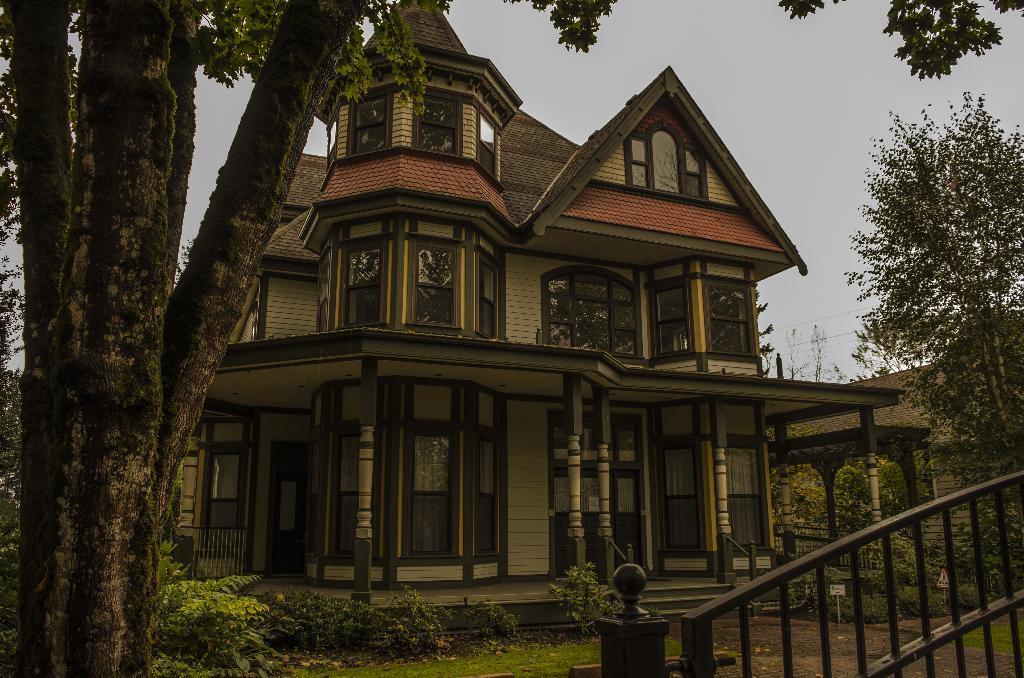Describe this image in one or two sentences. In this picture and house is highlighted. Sky is in blue color. In-front of this house there is a big tree. Plants are around this house. Plants are in green color. In-front of this house there is a grass. The gate. This house is made with brick walls and the wall is in cream color. There is a fence over this house. 